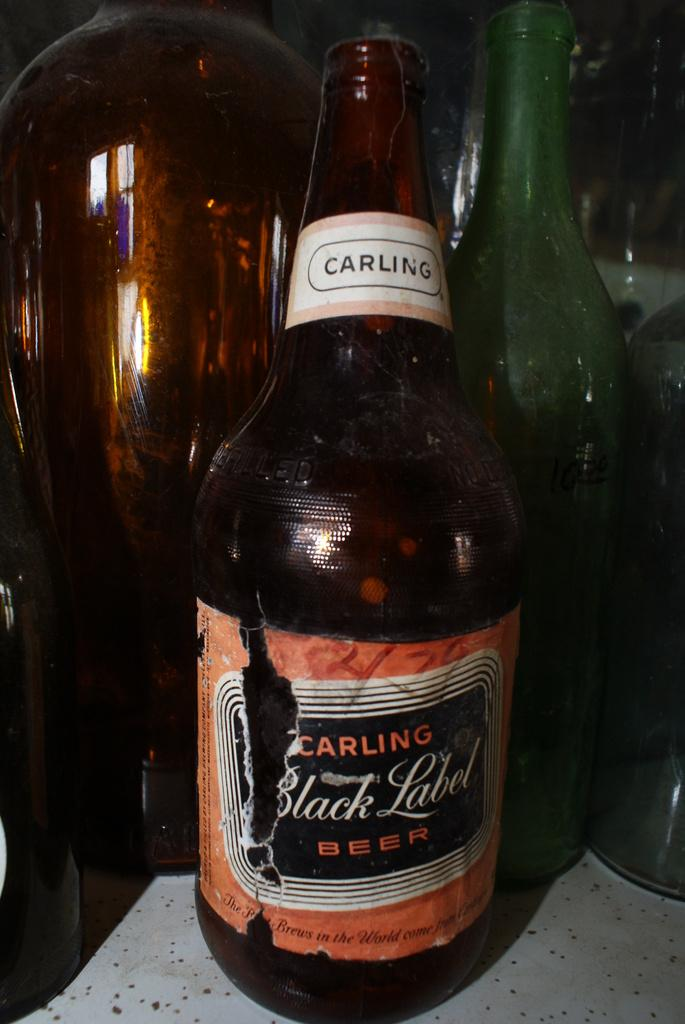<image>
Summarize the visual content of the image. A bottle of Carling black label beer with an orange label. 